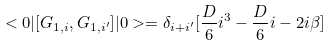<formula> <loc_0><loc_0><loc_500><loc_500>< 0 | [ G _ { 1 , i } , G _ { 1 , i ^ { \prime } } ] | 0 > = \delta _ { i + i ^ { \prime } } [ \frac { D } { 6 } i ^ { 3 } - \frac { D } { 6 } i - 2 i \beta ]</formula> 